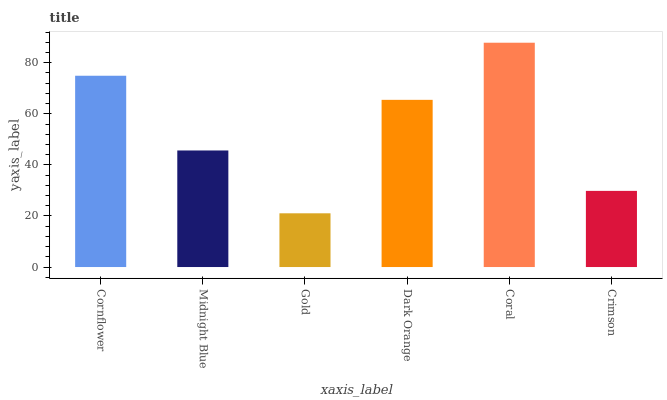Is Midnight Blue the minimum?
Answer yes or no. No. Is Midnight Blue the maximum?
Answer yes or no. No. Is Cornflower greater than Midnight Blue?
Answer yes or no. Yes. Is Midnight Blue less than Cornflower?
Answer yes or no. Yes. Is Midnight Blue greater than Cornflower?
Answer yes or no. No. Is Cornflower less than Midnight Blue?
Answer yes or no. No. Is Dark Orange the high median?
Answer yes or no. Yes. Is Midnight Blue the low median?
Answer yes or no. Yes. Is Crimson the high median?
Answer yes or no. No. Is Crimson the low median?
Answer yes or no. No. 